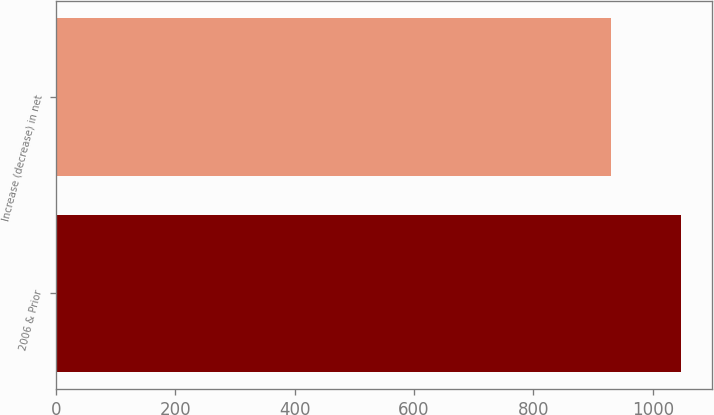<chart> <loc_0><loc_0><loc_500><loc_500><bar_chart><fcel>2006 & Prior<fcel>Increase (decrease) in net<nl><fcel>1047<fcel>930<nl></chart> 